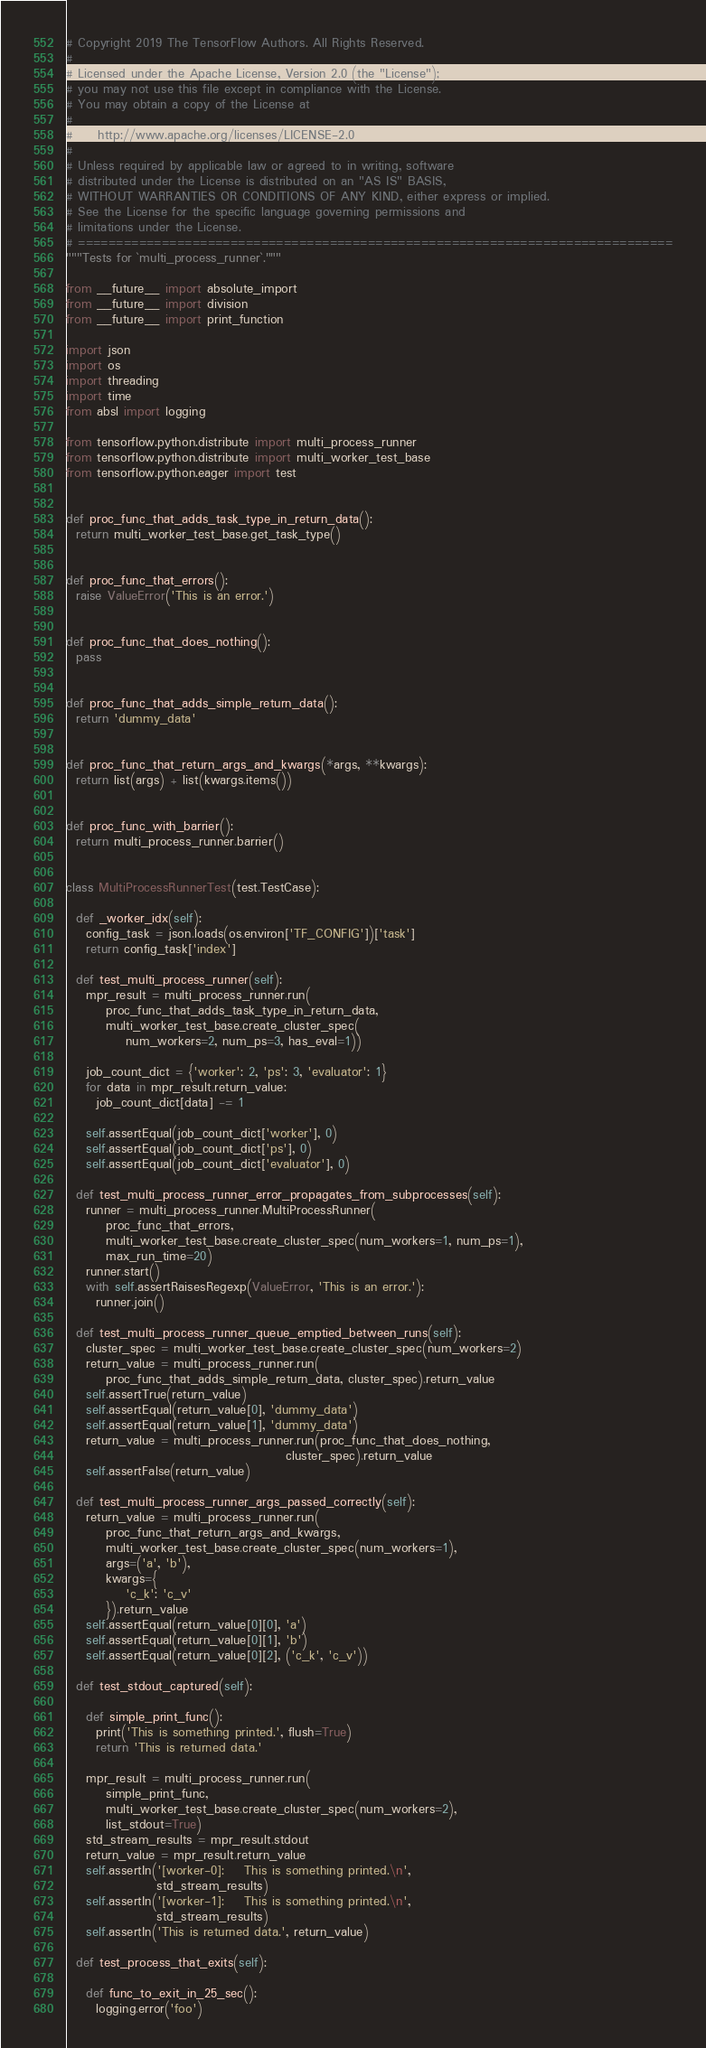<code> <loc_0><loc_0><loc_500><loc_500><_Python_># Copyright 2019 The TensorFlow Authors. All Rights Reserved.
#
# Licensed under the Apache License, Version 2.0 (the "License");
# you may not use this file except in compliance with the License.
# You may obtain a copy of the License at
#
#     http://www.apache.org/licenses/LICENSE-2.0
#
# Unless required by applicable law or agreed to in writing, software
# distributed under the License is distributed on an "AS IS" BASIS,
# WITHOUT WARRANTIES OR CONDITIONS OF ANY KIND, either express or implied.
# See the License for the specific language governing permissions and
# limitations under the License.
# ==============================================================================
"""Tests for `multi_process_runner`."""

from __future__ import absolute_import
from __future__ import division
from __future__ import print_function

import json
import os
import threading
import time
from absl import logging

from tensorflow.python.distribute import multi_process_runner
from tensorflow.python.distribute import multi_worker_test_base
from tensorflow.python.eager import test


def proc_func_that_adds_task_type_in_return_data():
  return multi_worker_test_base.get_task_type()


def proc_func_that_errors():
  raise ValueError('This is an error.')


def proc_func_that_does_nothing():
  pass


def proc_func_that_adds_simple_return_data():
  return 'dummy_data'


def proc_func_that_return_args_and_kwargs(*args, **kwargs):
  return list(args) + list(kwargs.items())


def proc_func_with_barrier():
  return multi_process_runner.barrier()


class MultiProcessRunnerTest(test.TestCase):

  def _worker_idx(self):
    config_task = json.loads(os.environ['TF_CONFIG'])['task']
    return config_task['index']

  def test_multi_process_runner(self):
    mpr_result = multi_process_runner.run(
        proc_func_that_adds_task_type_in_return_data,
        multi_worker_test_base.create_cluster_spec(
            num_workers=2, num_ps=3, has_eval=1))

    job_count_dict = {'worker': 2, 'ps': 3, 'evaluator': 1}
    for data in mpr_result.return_value:
      job_count_dict[data] -= 1

    self.assertEqual(job_count_dict['worker'], 0)
    self.assertEqual(job_count_dict['ps'], 0)
    self.assertEqual(job_count_dict['evaluator'], 0)

  def test_multi_process_runner_error_propagates_from_subprocesses(self):
    runner = multi_process_runner.MultiProcessRunner(
        proc_func_that_errors,
        multi_worker_test_base.create_cluster_spec(num_workers=1, num_ps=1),
        max_run_time=20)
    runner.start()
    with self.assertRaisesRegexp(ValueError, 'This is an error.'):
      runner.join()

  def test_multi_process_runner_queue_emptied_between_runs(self):
    cluster_spec = multi_worker_test_base.create_cluster_spec(num_workers=2)
    return_value = multi_process_runner.run(
        proc_func_that_adds_simple_return_data, cluster_spec).return_value
    self.assertTrue(return_value)
    self.assertEqual(return_value[0], 'dummy_data')
    self.assertEqual(return_value[1], 'dummy_data')
    return_value = multi_process_runner.run(proc_func_that_does_nothing,
                                            cluster_spec).return_value
    self.assertFalse(return_value)

  def test_multi_process_runner_args_passed_correctly(self):
    return_value = multi_process_runner.run(
        proc_func_that_return_args_and_kwargs,
        multi_worker_test_base.create_cluster_spec(num_workers=1),
        args=('a', 'b'),
        kwargs={
            'c_k': 'c_v'
        }).return_value
    self.assertEqual(return_value[0][0], 'a')
    self.assertEqual(return_value[0][1], 'b')
    self.assertEqual(return_value[0][2], ('c_k', 'c_v'))

  def test_stdout_captured(self):

    def simple_print_func():
      print('This is something printed.', flush=True)
      return 'This is returned data.'

    mpr_result = multi_process_runner.run(
        simple_print_func,
        multi_worker_test_base.create_cluster_spec(num_workers=2),
        list_stdout=True)
    std_stream_results = mpr_result.stdout
    return_value = mpr_result.return_value
    self.assertIn('[worker-0]:    This is something printed.\n',
                  std_stream_results)
    self.assertIn('[worker-1]:    This is something printed.\n',
                  std_stream_results)
    self.assertIn('This is returned data.', return_value)

  def test_process_that_exits(self):

    def func_to_exit_in_25_sec():
      logging.error('foo')</code> 